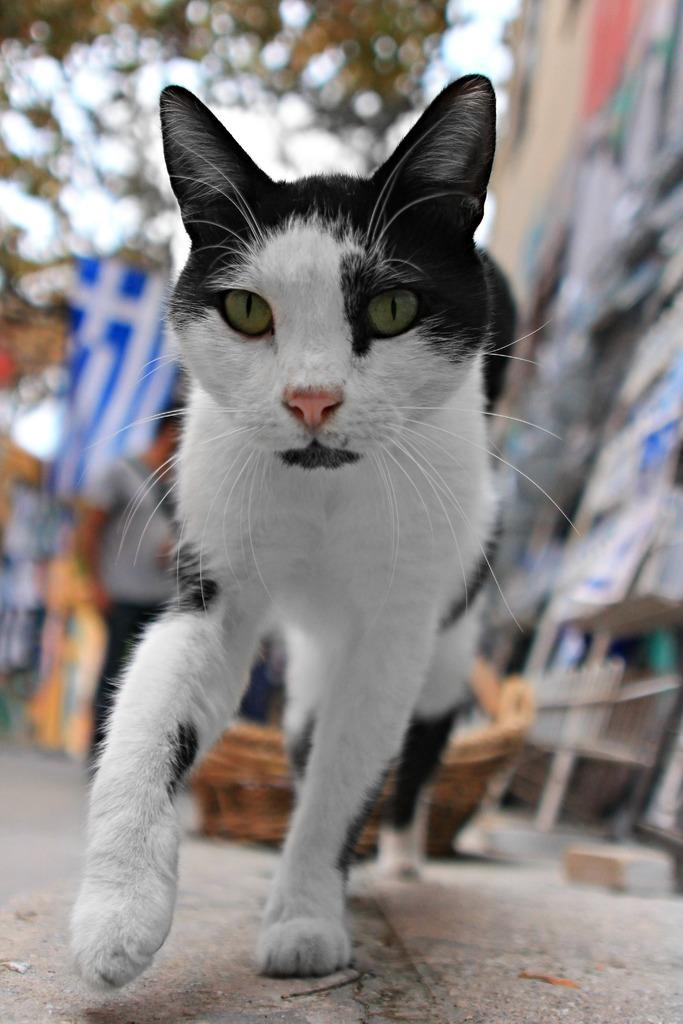What is the main subject in the center of the image? There is a cat in the center of the image. What can be seen in the background of the image? There are buildings and trees in the background of the image. What object is present in the image that represents a country or organization? There is a flag in the image. What surface is visible at the bottom of the image? There is a floor visible at the bottom of the image. How many spiders are crawling on the cat in the image? There are no spiders present in the image; the main subject is a cat. What type of glove is the cat wearing in the image? There is no glove present in the image, and the cat is not wearing any clothing or accessories. 